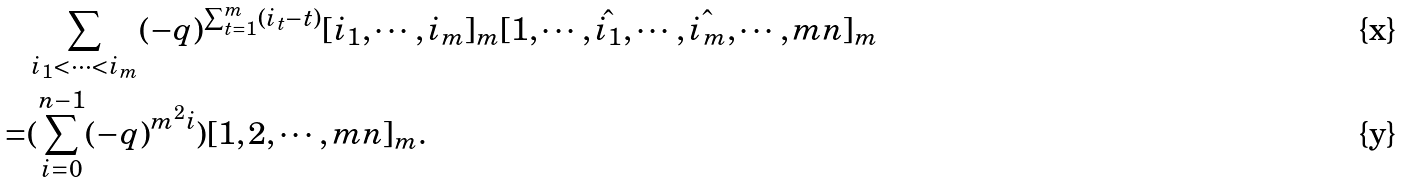Convert formula to latex. <formula><loc_0><loc_0><loc_500><loc_500>& \sum _ { i _ { 1 } < \cdots < i _ { m } } ( - q ) ^ { \sum _ { t = 1 } ^ { m } ( i _ { t } - t ) } [ i _ { 1 } , \cdots , i _ { m } ] _ { m } [ 1 , \cdots , \hat { i _ { 1 } } , \cdots , \hat { i _ { m } } , \cdots , m n ] _ { m } \\ = & ( \sum _ { i = 0 } ^ { n - 1 } ( - q ) ^ { m ^ { 2 } i } ) [ 1 , 2 , \cdots , m n ] _ { m } .</formula> 